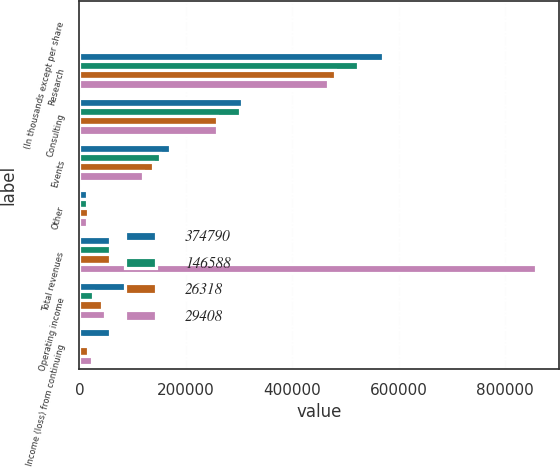Convert chart to OTSL. <chart><loc_0><loc_0><loc_500><loc_500><stacked_bar_chart><ecel><fcel>(In thousands except per share<fcel>Research<fcel>Consulting<fcel>Events<fcel>Other<fcel>Total revenues<fcel>Operating income<fcel>Income (loss) from continuing<nl><fcel>374790<fcel>2006<fcel>571217<fcel>305231<fcel>169434<fcel>14439<fcel>58192<fcel>103250<fcel>58192<nl><fcel>146588<fcel>2005<fcel>523033<fcel>301074<fcel>151339<fcel>13558<fcel>58192<fcel>25280<fcel>2437<nl><fcel>26318<fcel>2004<fcel>480486<fcel>259419<fcel>138393<fcel>15523<fcel>58192<fcel>42659<fcel>16889<nl><fcel>29408<fcel>2003<fcel>466907<fcel>258628<fcel>119355<fcel>13556<fcel>858446<fcel>47333<fcel>23589<nl></chart> 